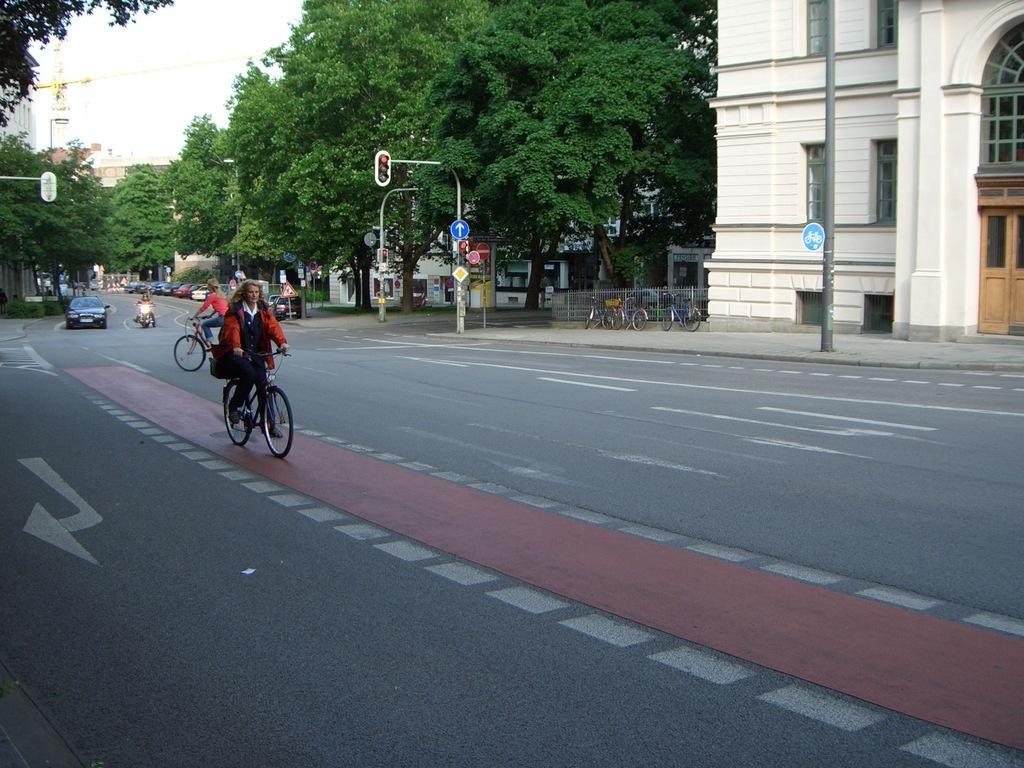Can you describe this image briefly? In this picture we can see group of people, few are riding bicycles on the road, in the background we can see few traffic lights, trees, vehicles, fence, sign boards and buildings, and also we can see a crane. 